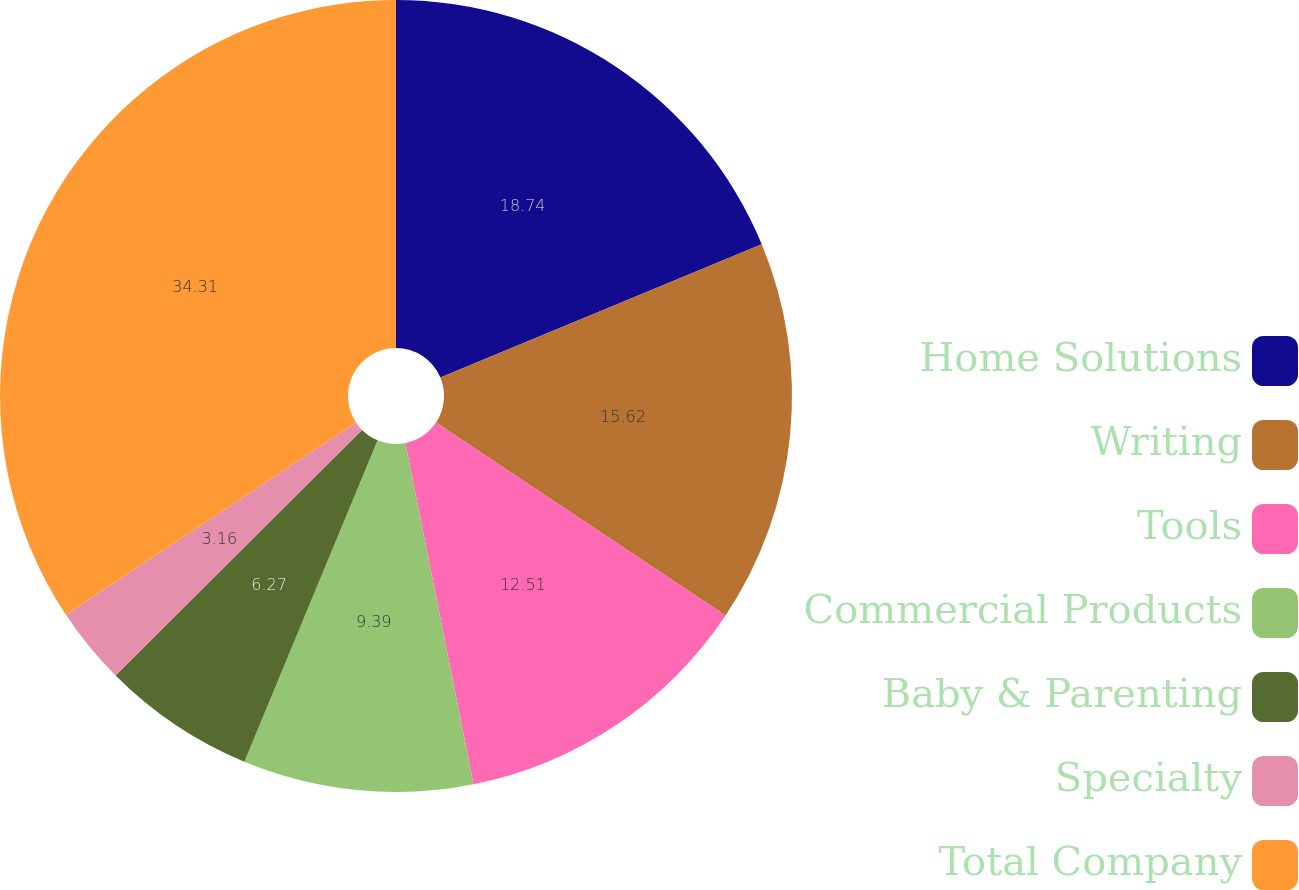<chart> <loc_0><loc_0><loc_500><loc_500><pie_chart><fcel>Home Solutions<fcel>Writing<fcel>Tools<fcel>Commercial Products<fcel>Baby & Parenting<fcel>Specialty<fcel>Total Company<nl><fcel>18.74%<fcel>15.62%<fcel>12.51%<fcel>9.39%<fcel>6.27%<fcel>3.16%<fcel>34.32%<nl></chart> 